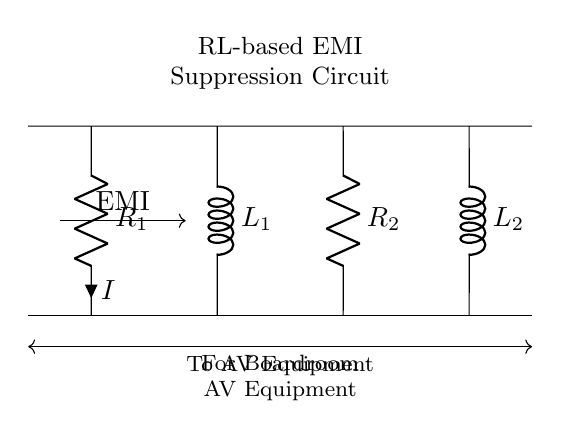What type of circuit is shown? The diagram represents an RL-based electromagnetic interference suppression circuit, which includes resistors and inductors specifically designed to mitigate EMI.
Answer: RL-based EMI Suppression Circuit How many resistors are present in the circuit? The circuit contains two resistors, labeled R1 and R2, which are essential for controlling the current and dissipating energy.
Answer: Two What is the function of the inductors in this circuit? The inductors, L1 and L2, work to suppress high-frequency noise and store energy in the magnetic field, thus reducing electromagnetic interference in the application.
Answer: Suppress EMI What is the current direction indicated in the circuit? The current, labeled as I, is flowing from R1 down to the ground, representing the path of electric charge through the circuit components.
Answer: Downwards What does the arrow indicate in the circuit? The arrow represents the direction of the electromagnetic interference (EMI) entering the circuit and is an important aspect of how the circuit interacts with external noise.
Answer: EMI direction What is the significance of this circuit in a boardroom setting? This circuit is important as it ensures clear audio and visual signals by blocking unwanted interference, providing a more reliable experience during presentations and meetings.
Answer: Clear AV signals 